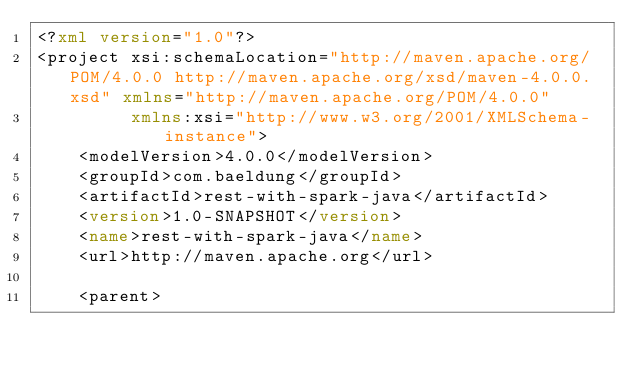<code> <loc_0><loc_0><loc_500><loc_500><_XML_><?xml version="1.0"?>
<project xsi:schemaLocation="http://maven.apache.org/POM/4.0.0 http://maven.apache.org/xsd/maven-4.0.0.xsd" xmlns="http://maven.apache.org/POM/4.0.0"
         xmlns:xsi="http://www.w3.org/2001/XMLSchema-instance">
    <modelVersion>4.0.0</modelVersion>
    <groupId>com.baeldung</groupId>
    <artifactId>rest-with-spark-java</artifactId>
    <version>1.0-SNAPSHOT</version>
    <name>rest-with-spark-java</name>
    <url>http://maven.apache.org</url>

    <parent></code> 